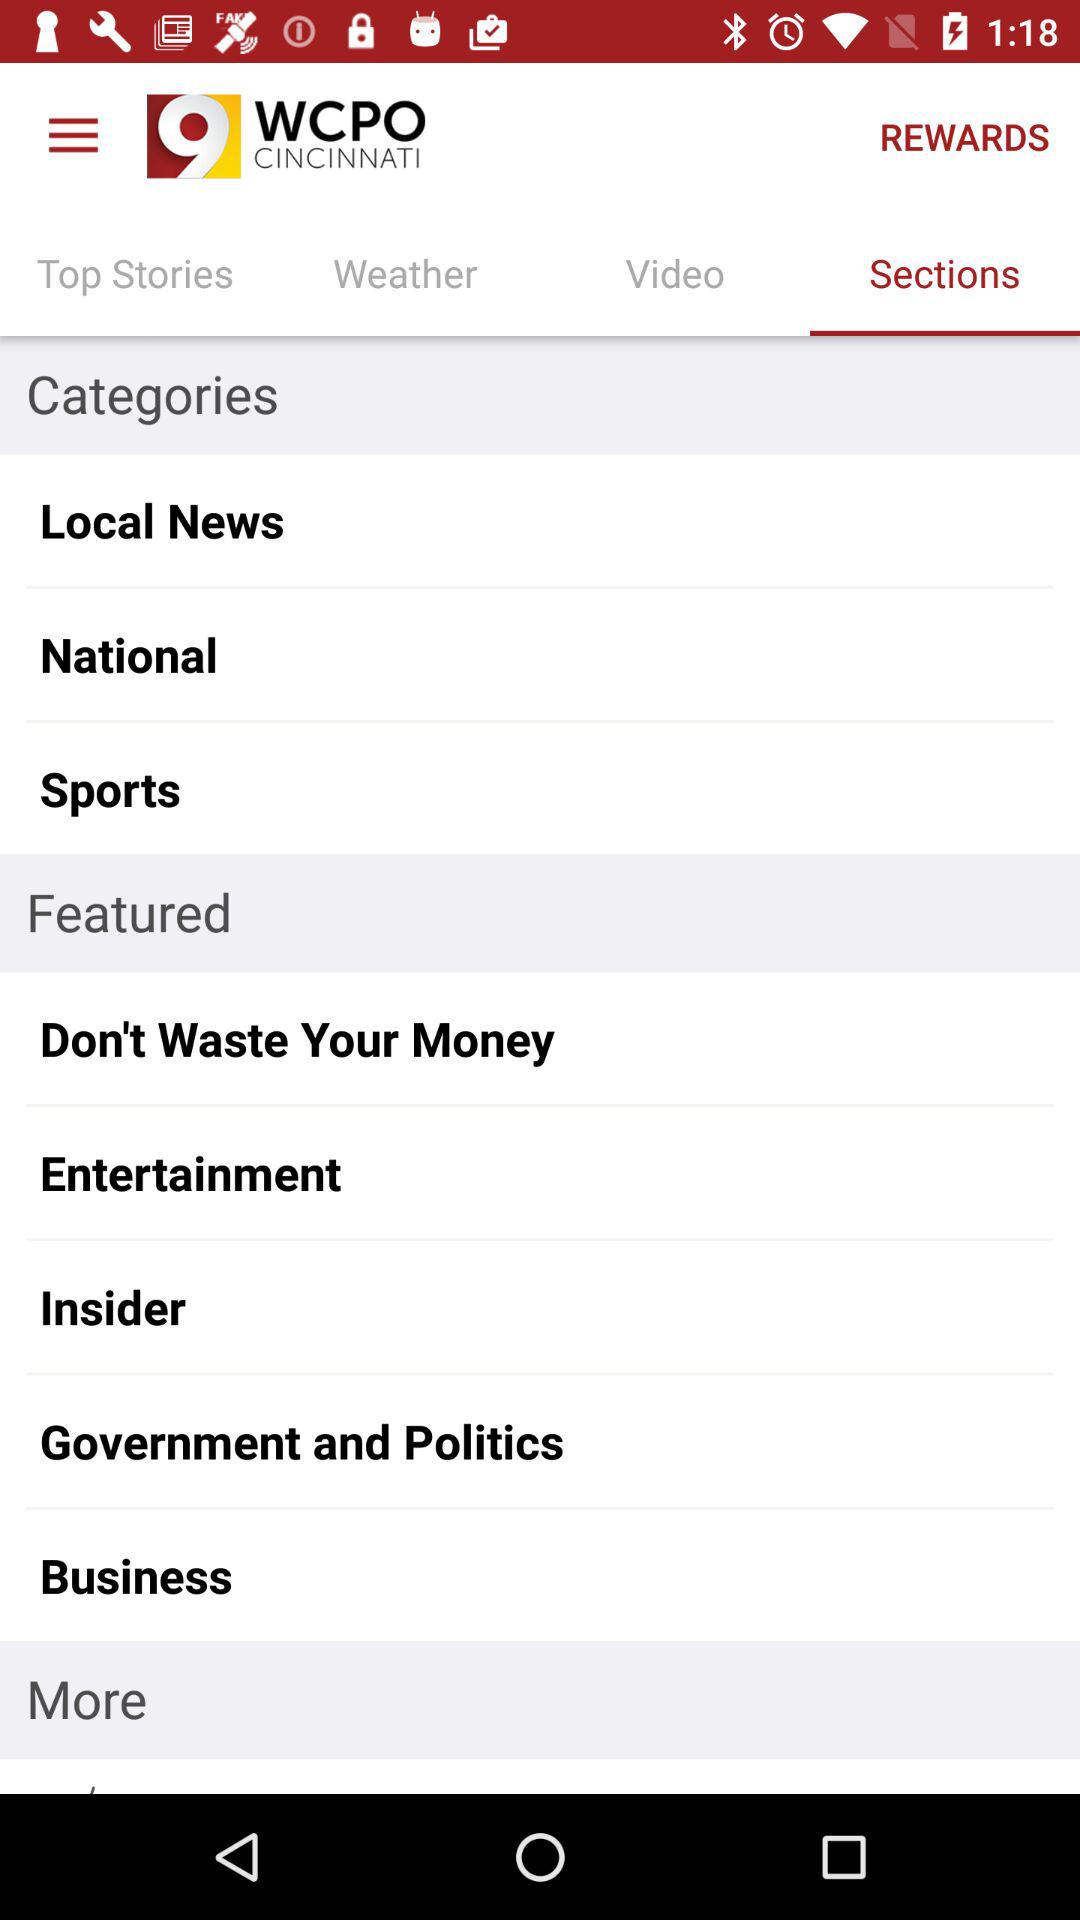What is the name of the application? The name of the application is "WCPO CINCINNATI". 